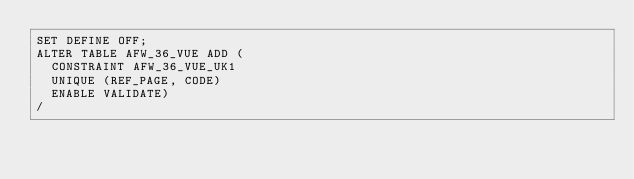<code> <loc_0><loc_0><loc_500><loc_500><_SQL_>SET DEFINE OFF;
ALTER TABLE AFW_36_VUE ADD (
  CONSTRAINT AFW_36_VUE_UK1
  UNIQUE (REF_PAGE, CODE)
  ENABLE VALIDATE)
/
</code> 